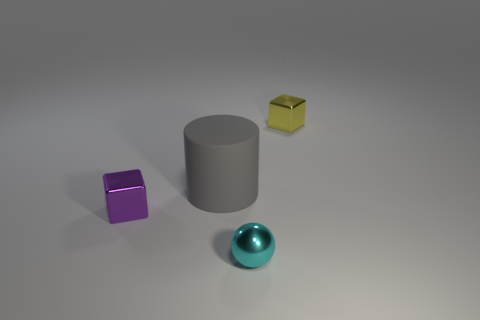Add 3 big rubber spheres. How many objects exist? 7 Subtract all spheres. How many objects are left? 3 Add 4 cylinders. How many cylinders exist? 5 Subtract 1 cyan spheres. How many objects are left? 3 Subtract all purple things. Subtract all cyan things. How many objects are left? 2 Add 1 small yellow objects. How many small yellow objects are left? 2 